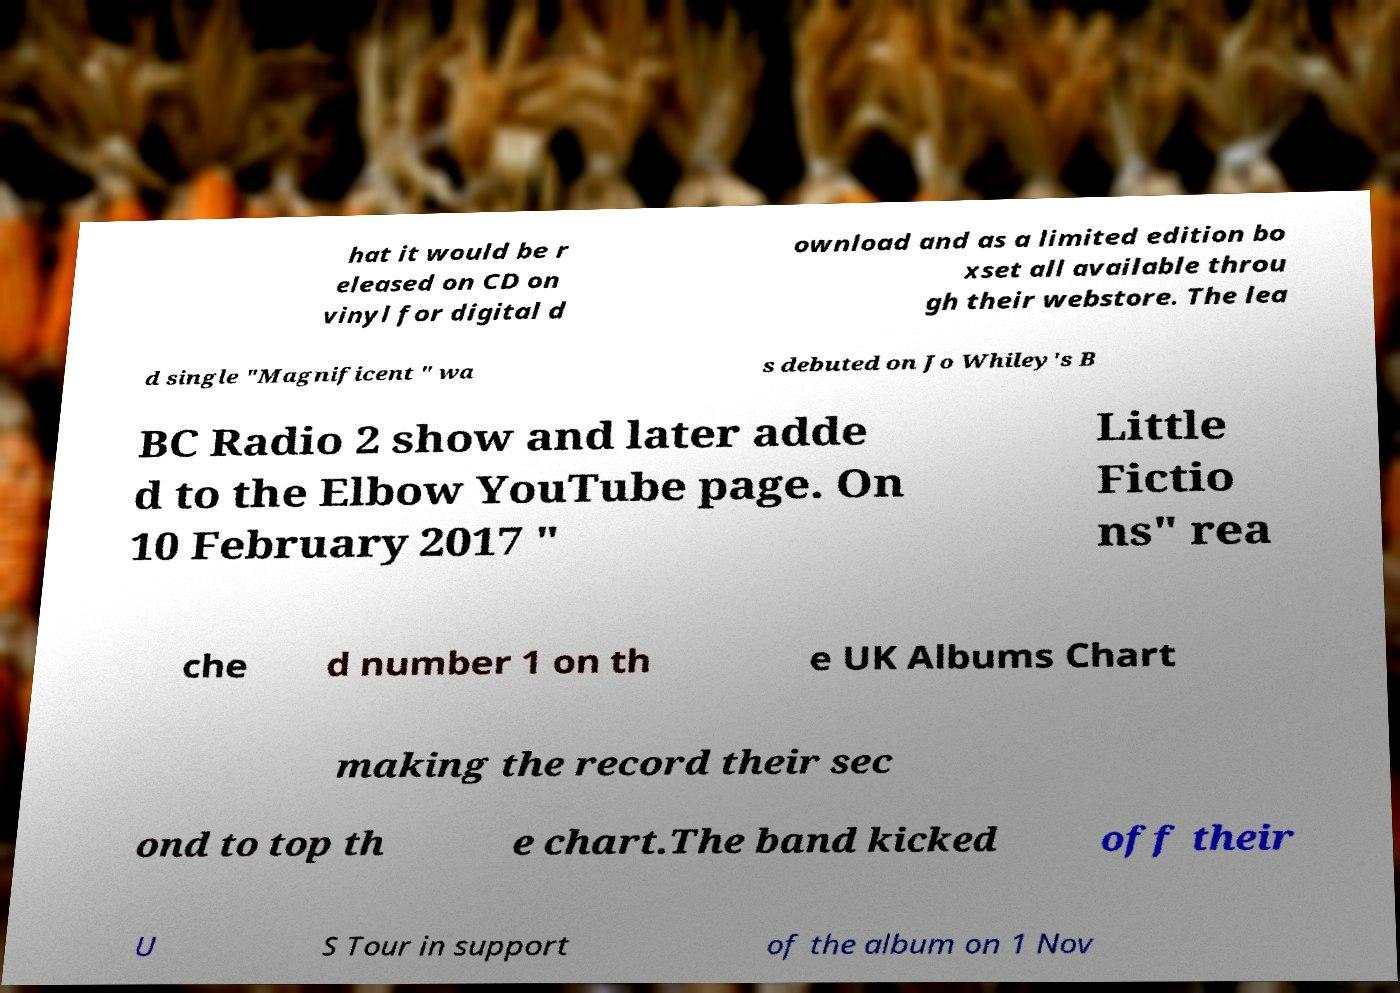Could you assist in decoding the text presented in this image and type it out clearly? hat it would be r eleased on CD on vinyl for digital d ownload and as a limited edition bo xset all available throu gh their webstore. The lea d single "Magnificent " wa s debuted on Jo Whiley's B BC Radio 2 show and later adde d to the Elbow YouTube page. On 10 February 2017 " Little Fictio ns" rea che d number 1 on th e UK Albums Chart making the record their sec ond to top th e chart.The band kicked off their U S Tour in support of the album on 1 Nov 